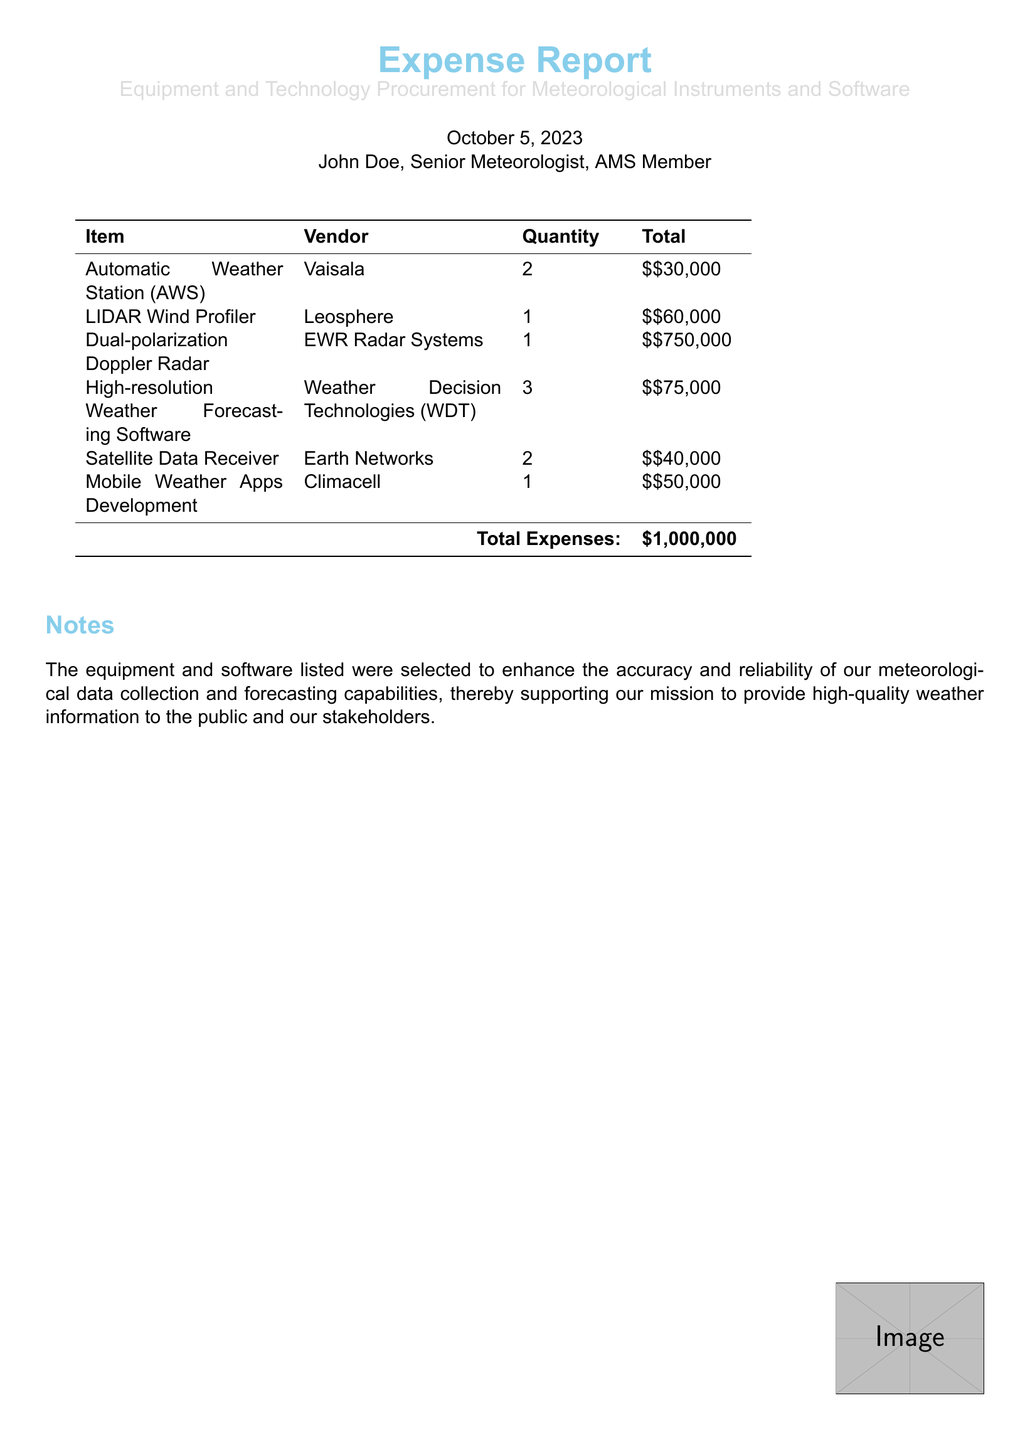What is the total cost of the Automatic Weather Stations? The total cost for the Automatic Weather Stations is calculated as 2 units at $30,000 each, which equals $30,000.
Answer: $30,000 Who is the vendor for the Dual-polarization Doppler Radar? The vendor for the Dual-polarization Doppler Radar listed in the document is EWR Radar Systems.
Answer: EWR Radar Systems What is the total number of items purchased? The total number of items purchased can be found by adding the quantities of all items, which equals 2 + 1 + 1 + 3 + 2 + 1 = 10 units.
Answer: 10 How much was spent on LIDAR Wind Profiler? The amount spent on the LIDAR Wind Profiler is directly stated in the document as $60,000.
Answer: $60,000 What is the total expense reported? The total expense reported in the document is summarized at the bottom as $1,000,000.
Answer: $1,000,000 Which item was developed by Climacell? The item developed by Climacell, as listed in the report, is the Mobile Weather Apps Development.
Answer: Mobile Weather Apps Development What purpose do the listed items serve? The listed items serve to enhance the accuracy and reliability of meteorological data collection and forecasting capabilities.
Answer: Enhance data accuracy and reliability How many vendors are mentioned in the report? The total number of different vendors mentioned in the report can be counted from the list, which shows five distinct vendors.
Answer: 5 What is the price of the Satellite Data Receiver? The price of the Satellite Data Receiver per unit is specified in the document as $20,000.
Answer: $20,000 